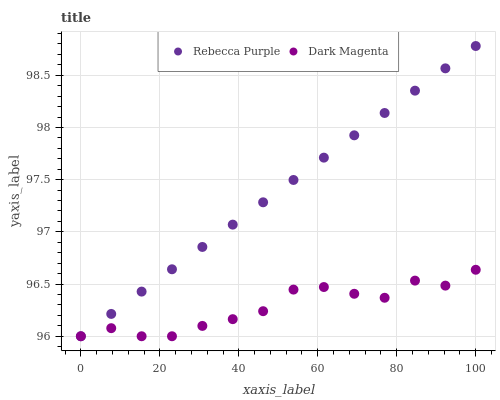Does Dark Magenta have the minimum area under the curve?
Answer yes or no. Yes. Does Rebecca Purple have the maximum area under the curve?
Answer yes or no. Yes. Does Dark Magenta have the maximum area under the curve?
Answer yes or no. No. Is Rebecca Purple the smoothest?
Answer yes or no. Yes. Is Dark Magenta the roughest?
Answer yes or no. Yes. Is Dark Magenta the smoothest?
Answer yes or no. No. Does Rebecca Purple have the lowest value?
Answer yes or no. Yes. Does Rebecca Purple have the highest value?
Answer yes or no. Yes. Does Dark Magenta have the highest value?
Answer yes or no. No. Does Rebecca Purple intersect Dark Magenta?
Answer yes or no. Yes. Is Rebecca Purple less than Dark Magenta?
Answer yes or no. No. Is Rebecca Purple greater than Dark Magenta?
Answer yes or no. No. 